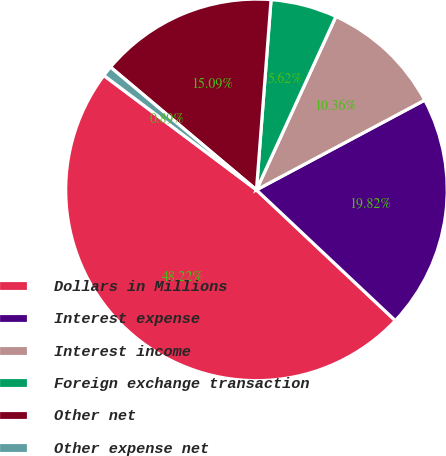<chart> <loc_0><loc_0><loc_500><loc_500><pie_chart><fcel>Dollars in Millions<fcel>Interest expense<fcel>Interest income<fcel>Foreign exchange transaction<fcel>Other net<fcel>Other expense net<nl><fcel>48.22%<fcel>19.82%<fcel>10.36%<fcel>5.62%<fcel>15.09%<fcel>0.89%<nl></chart> 